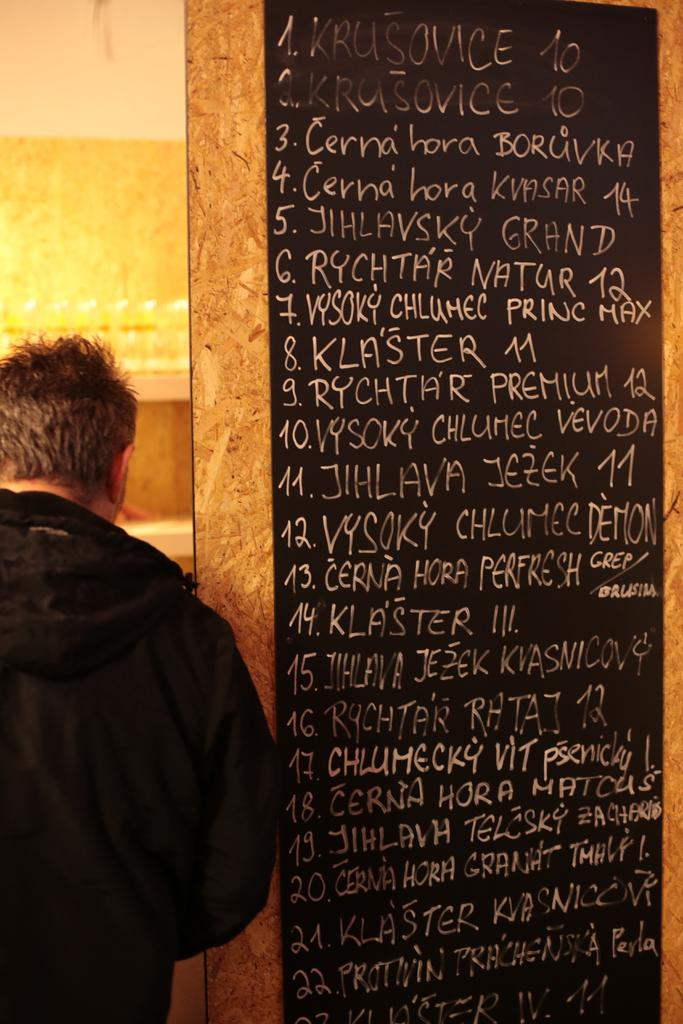What is present in the image that serves as a background? There is a wall in the image that serves as a background. Who is present in the image? There is a man in the image. What is the man wearing? The man is wearing a black jacket. Can you see any snails on the wall in the image? There are no snails present on the wall in the image. How many mountains are visible in the image? There are no mountains visible in the image. 